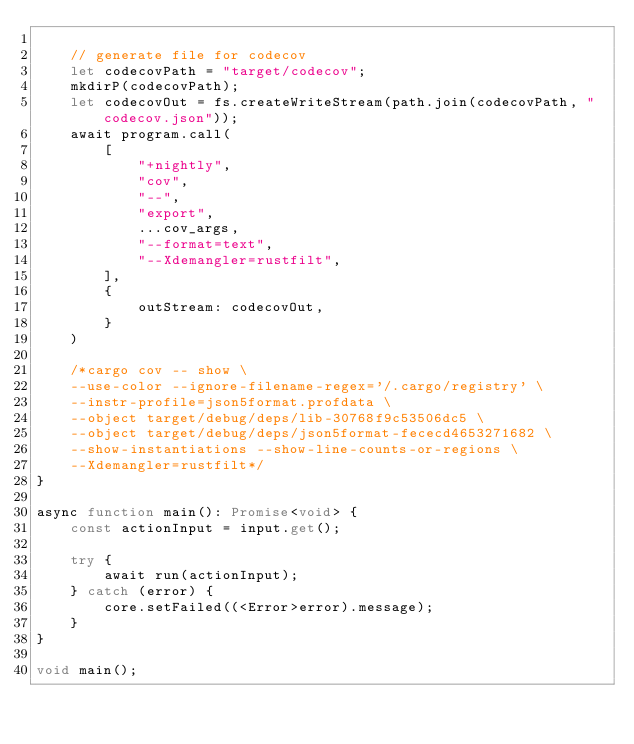Convert code to text. <code><loc_0><loc_0><loc_500><loc_500><_TypeScript_>
    // generate file for codecov
    let codecovPath = "target/codecov";
    mkdirP(codecovPath);
    let codecovOut = fs.createWriteStream(path.join(codecovPath, "codecov.json"));
    await program.call(
        [
            "+nightly",
            "cov",
            "--",
            "export",
            ...cov_args,
            "--format=text",
            "--Xdemangler=rustfilt",
        ],
        {
            outStream: codecovOut,
        }
    )

    /*cargo cov -- show \
    --use-color --ignore-filename-regex='/.cargo/registry' \
    --instr-profile=json5format.profdata \
    --object target/debug/deps/lib-30768f9c53506dc5 \
    --object target/debug/deps/json5format-fececd4653271682 \
    --show-instantiations --show-line-counts-or-regions \
    --Xdemangler=rustfilt*/
}

async function main(): Promise<void> {
    const actionInput = input.get();

    try {
        await run(actionInput);
    } catch (error) {
        core.setFailed((<Error>error).message);
    }
}

void main();</code> 